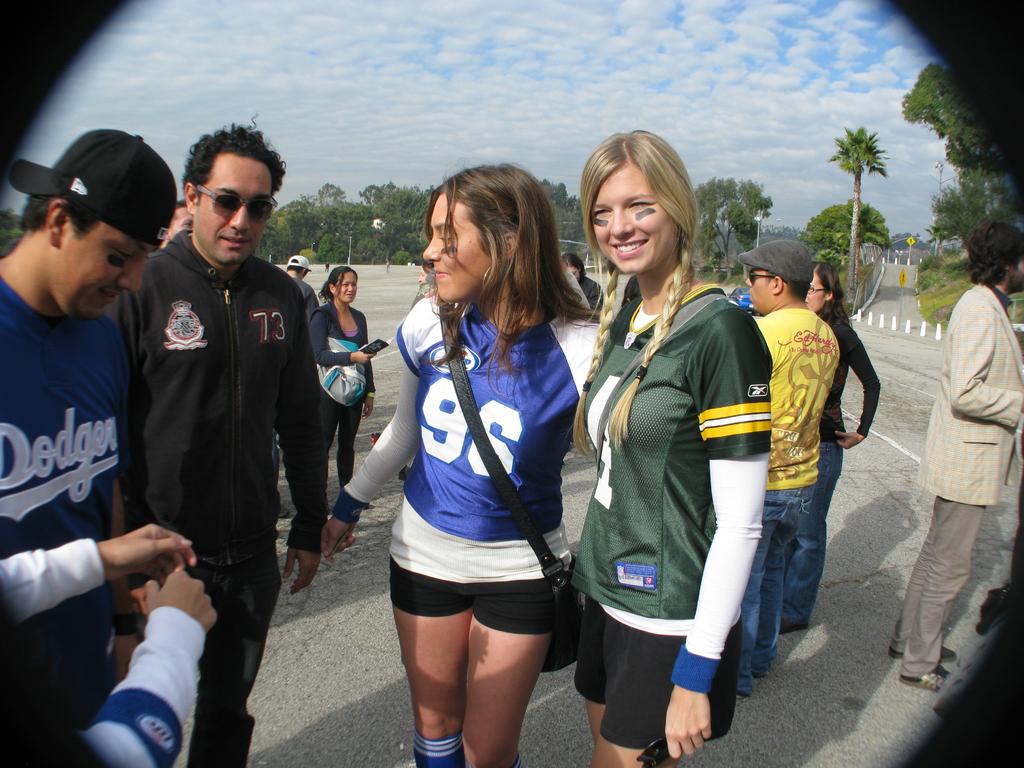What team is on the man's jersey?
Provide a short and direct response. Dodgers. What is the girls jersey number?
Keep it short and to the point. 96. 